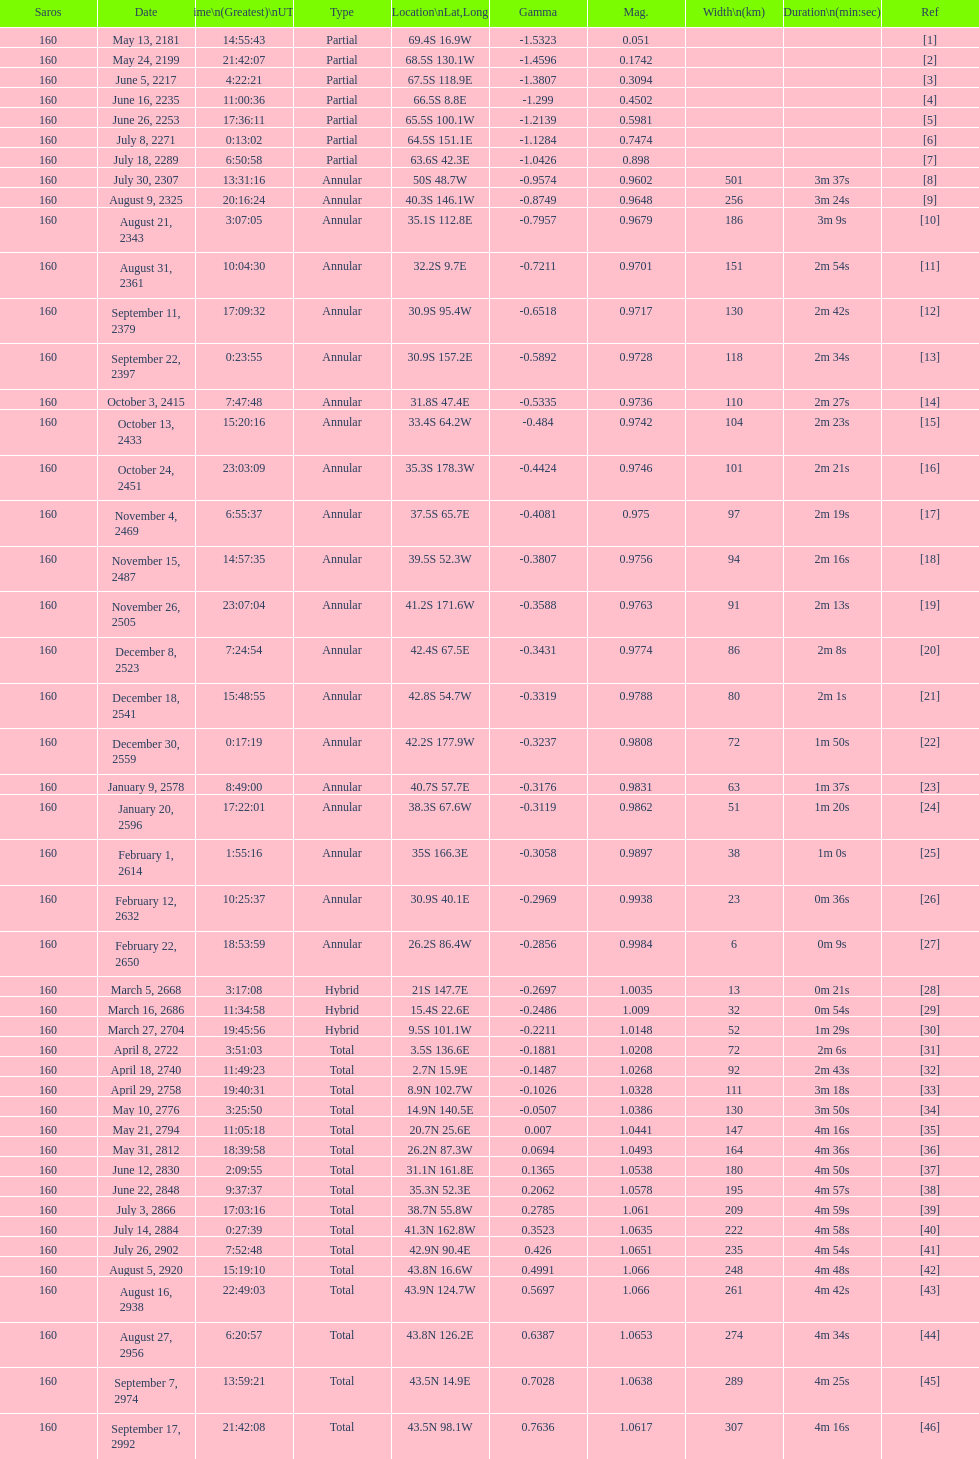When did the premier solar saros with a magnitude of more than March 5, 2668. 